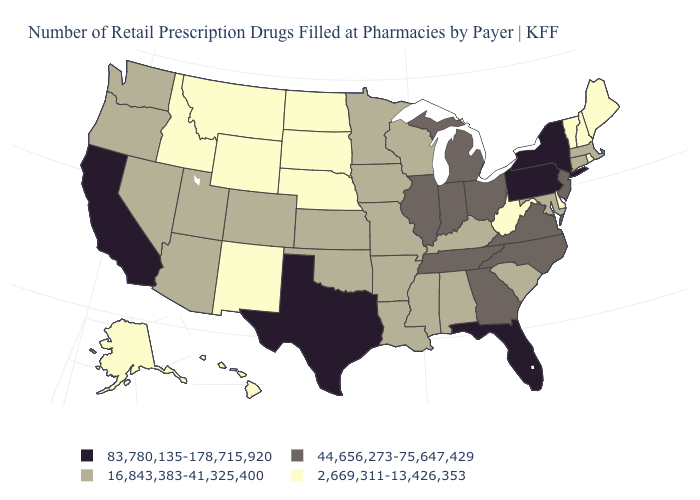Does Hawaii have the lowest value in the West?
Answer briefly. Yes. What is the value of Massachusetts?
Keep it brief. 16,843,383-41,325,400. What is the lowest value in the USA?
Be succinct. 2,669,311-13,426,353. What is the value of Connecticut?
Short answer required. 16,843,383-41,325,400. Name the states that have a value in the range 83,780,135-178,715,920?
Write a very short answer. California, Florida, New York, Pennsylvania, Texas. Name the states that have a value in the range 16,843,383-41,325,400?
Concise answer only. Alabama, Arizona, Arkansas, Colorado, Connecticut, Iowa, Kansas, Kentucky, Louisiana, Maryland, Massachusetts, Minnesota, Mississippi, Missouri, Nevada, Oklahoma, Oregon, South Carolina, Utah, Washington, Wisconsin. Which states have the highest value in the USA?
Give a very brief answer. California, Florida, New York, Pennsylvania, Texas. Does Minnesota have the lowest value in the MidWest?
Answer briefly. No. Name the states that have a value in the range 44,656,273-75,647,429?
Answer briefly. Georgia, Illinois, Indiana, Michigan, New Jersey, North Carolina, Ohio, Tennessee, Virginia. Name the states that have a value in the range 2,669,311-13,426,353?
Short answer required. Alaska, Delaware, Hawaii, Idaho, Maine, Montana, Nebraska, New Hampshire, New Mexico, North Dakota, Rhode Island, South Dakota, Vermont, West Virginia, Wyoming. Which states hav the highest value in the South?
Short answer required. Florida, Texas. Does Texas have the same value as California?
Short answer required. Yes. What is the highest value in states that border Mississippi?
Give a very brief answer. 44,656,273-75,647,429. What is the value of Tennessee?
Be succinct. 44,656,273-75,647,429. Name the states that have a value in the range 16,843,383-41,325,400?
Concise answer only. Alabama, Arizona, Arkansas, Colorado, Connecticut, Iowa, Kansas, Kentucky, Louisiana, Maryland, Massachusetts, Minnesota, Mississippi, Missouri, Nevada, Oklahoma, Oregon, South Carolina, Utah, Washington, Wisconsin. 